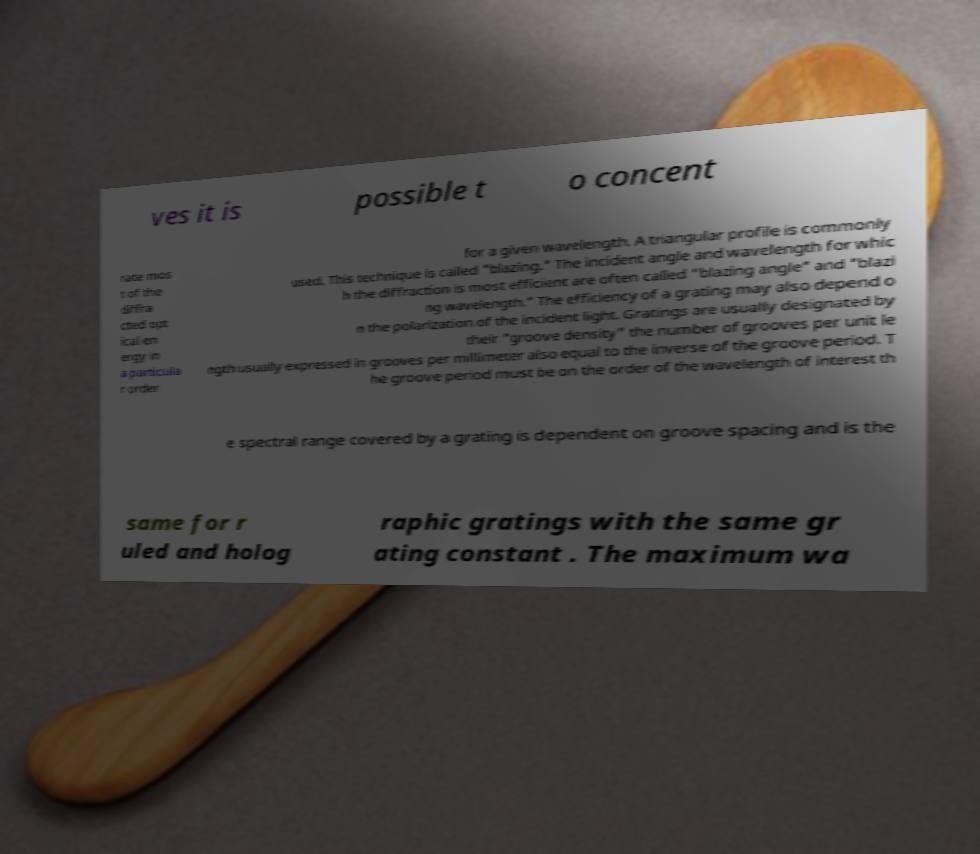I need the written content from this picture converted into text. Can you do that? ves it is possible t o concent rate mos t of the diffra cted opt ical en ergy in a particula r order for a given wavelength. A triangular profile is commonly used. This technique is called "blazing." The incident angle and wavelength for whic h the diffraction is most efficient are often called "blazing angle" and "blazi ng wavelength." The efficiency of a grating may also depend o n the polarization of the incident light. Gratings are usually designated by their "groove density" the number of grooves per unit le ngth usually expressed in grooves per millimeter also equal to the inverse of the groove period. T he groove period must be on the order of the wavelength of interest th e spectral range covered by a grating is dependent on groove spacing and is the same for r uled and holog raphic gratings with the same gr ating constant . The maximum wa 